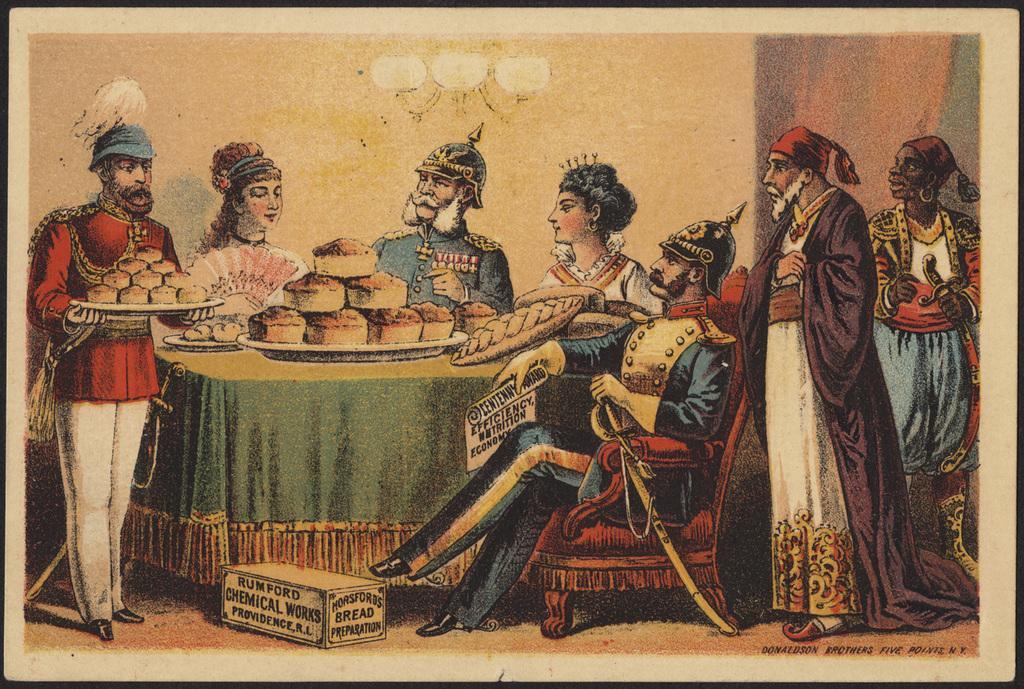How would you summarize this image in a sentence or two? This picture looks like a painting. On the right there are two person standing near to the chair. Here we can see another person who is wearing helmet and green color dress. He is sitting on the chair and he is also holding a paper. On the table we can see bread, tray, plate and other food items. On the bottom we can see a box. On the left there is a man who is holding the tray. On the top there is a chandelier. Here we can see two women who are standing near to the wall. 